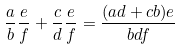Convert formula to latex. <formula><loc_0><loc_0><loc_500><loc_500>\frac { a } { b } \frac { e } { f } + \frac { c } { d } \frac { e } { f } = \frac { ( a d + c b ) e } { b d f }</formula> 